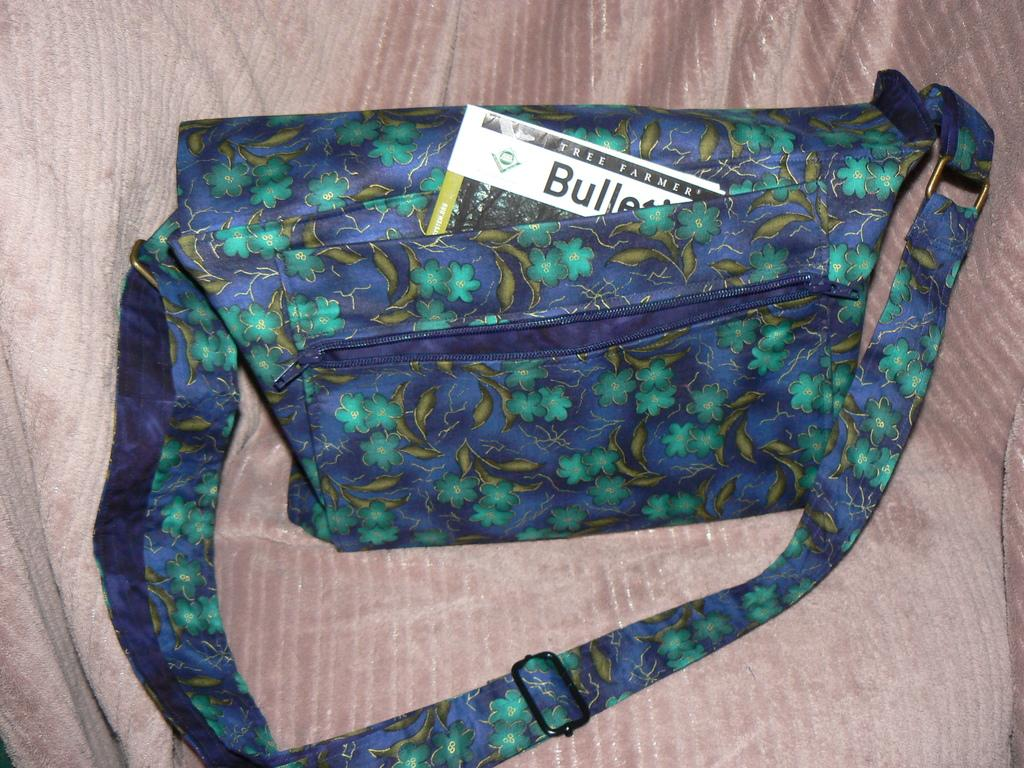What color is the handbag in the image? The handbag is blue. What design can be seen on the handbag? The handbag has a green flowers design. What color is the background in the image? The background color is pink. What type of beast can be seen walking on the handbag in the image? There is no beast present in the image; it only features a handbag with a green flowers design. How many shoes are visible in the image? There are no shoes visible in the image; it only features a handbag. 